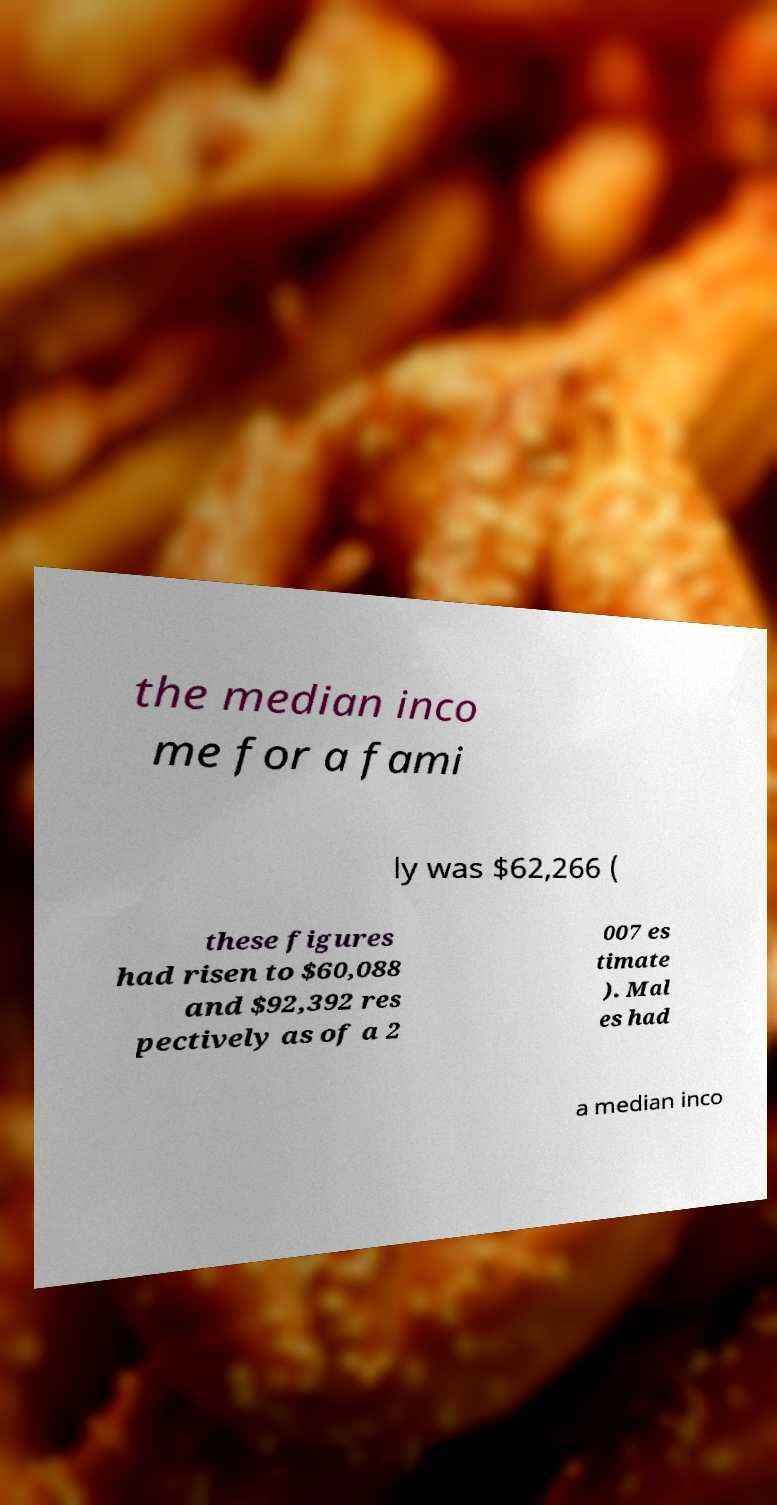I need the written content from this picture converted into text. Can you do that? the median inco me for a fami ly was $62,266 ( these figures had risen to $60,088 and $92,392 res pectively as of a 2 007 es timate ). Mal es had a median inco 